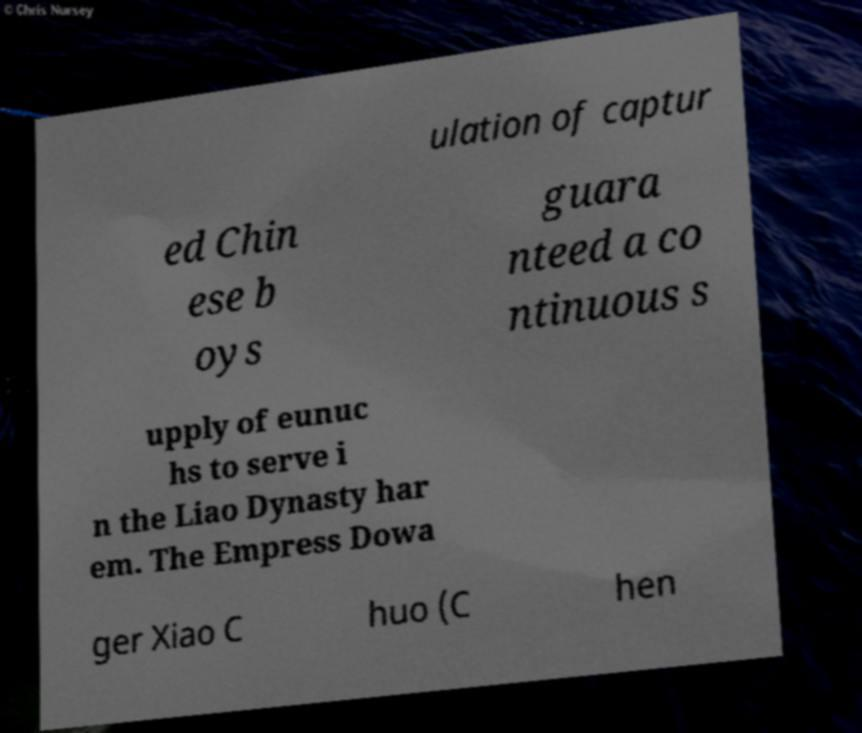Could you extract and type out the text from this image? ulation of captur ed Chin ese b oys guara nteed a co ntinuous s upply of eunuc hs to serve i n the Liao Dynasty har em. The Empress Dowa ger Xiao C huo (C hen 